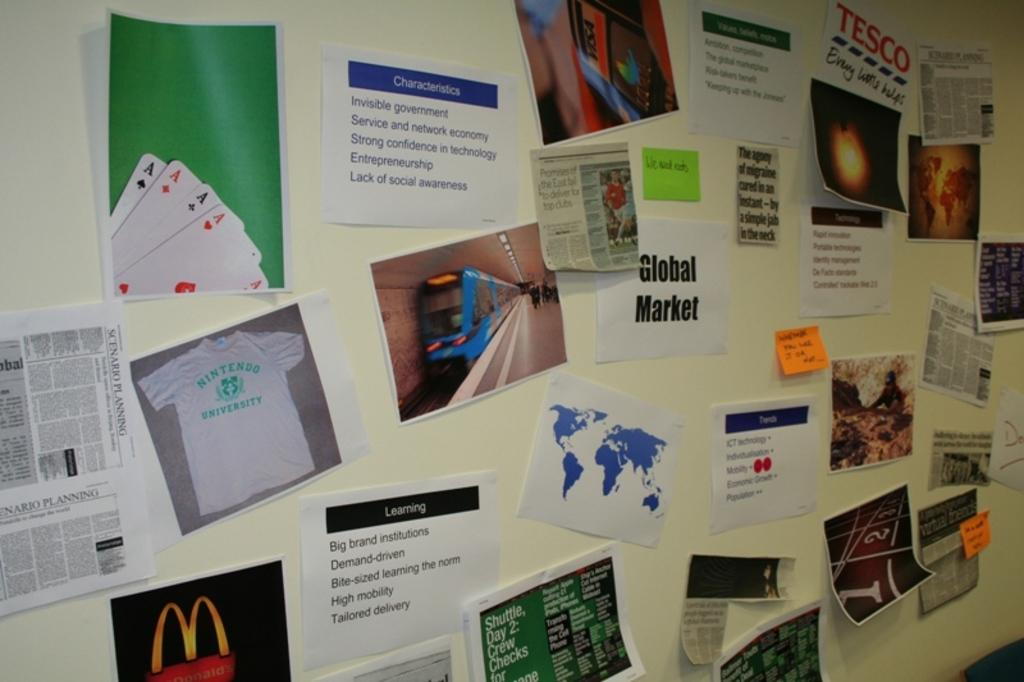What can be seen on the posters in the image? The posters have text written on them. Where are the posters located in the image? The posters are located in the center of the image. How many birds are flying in the steam in the image? There are no birds or steam present in the image. 